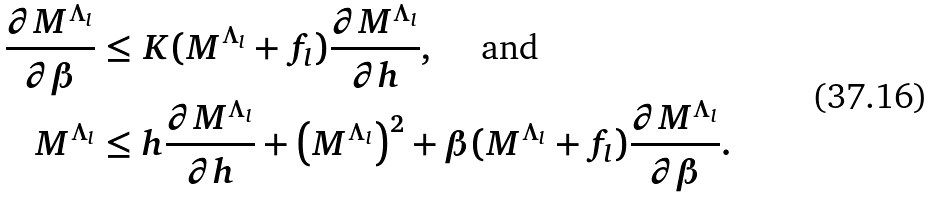<formula> <loc_0><loc_0><loc_500><loc_500>\frac { \partial M ^ { \Lambda _ { l } } } { \partial \beta } & \leq K ( M ^ { \Lambda _ { l } } + f _ { l } ) \frac { \partial M ^ { \Lambda _ { l } } } { \partial h } , \quad \text { and } \\ M ^ { \Lambda _ { l } } & \leq h \frac { \partial M ^ { \Lambda _ { l } } } { \partial h } + \left ( M ^ { \Lambda _ { l } } \right ) ^ { 2 } + \beta ( M ^ { \Lambda _ { l } } + f _ { l } ) \frac { \partial M ^ { \Lambda _ { l } } } { \partial \beta } .</formula> 